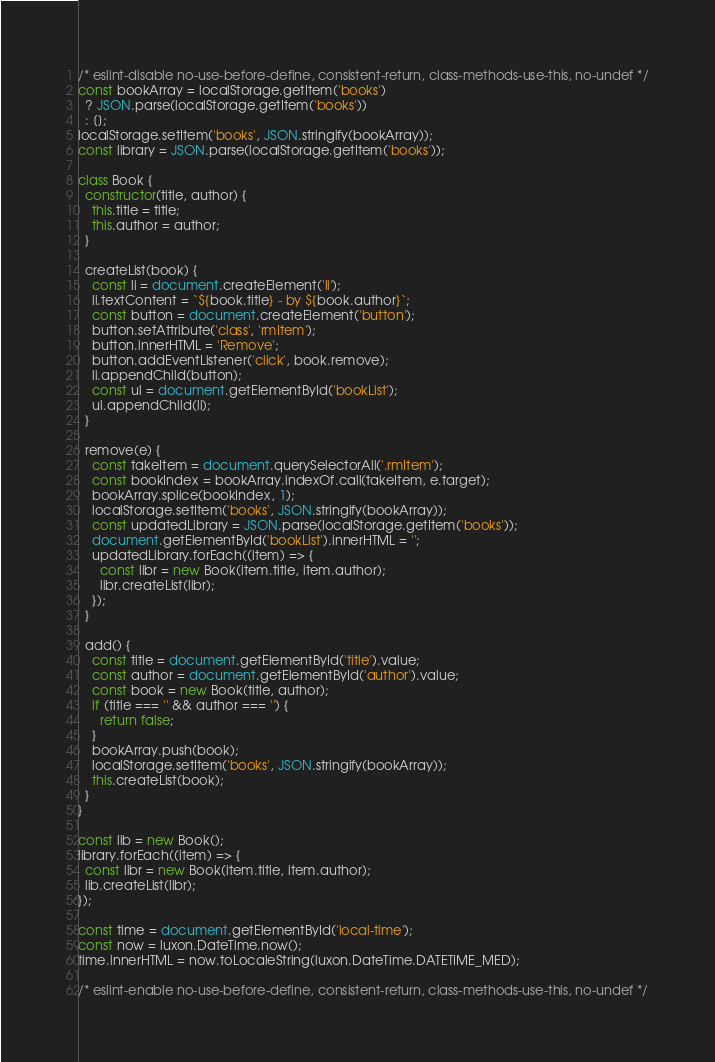<code> <loc_0><loc_0><loc_500><loc_500><_JavaScript_>/* eslint-disable no-use-before-define, consistent-return, class-methods-use-this, no-undef */
const bookArray = localStorage.getItem('books')
  ? JSON.parse(localStorage.getItem('books'))
  : [];
localStorage.setItem('books', JSON.stringify(bookArray));
const library = JSON.parse(localStorage.getItem('books'));

class Book {
  constructor(title, author) {
    this.title = title;
    this.author = author;
  }

  createList(book) {
    const li = document.createElement('li');
    li.textContent = `${book.title} - by ${book.author}`;
    const button = document.createElement('button');
    button.setAttribute('class', 'rmItem');
    button.innerHTML = 'Remove';
    button.addEventListener('click', book.remove);
    li.appendChild(button);
    const ul = document.getElementById('bookList');
    ul.appendChild(li);
  }

  remove(e) {
    const takeItem = document.querySelectorAll('.rmItem');
    const bookIndex = bookArray.indexOf.call(takeItem, e.target);
    bookArray.splice(bookIndex, 1);
    localStorage.setItem('books', JSON.stringify(bookArray));
    const updatedLibrary = JSON.parse(localStorage.getItem('books'));
    document.getElementById('bookList').innerHTML = '';
    updatedLibrary.forEach((item) => {
      const libr = new Book(item.title, item.author);
      libr.createList(libr);
    });
  }

  add() {
    const title = document.getElementById('title').value;
    const author = document.getElementById('author').value;
    const book = new Book(title, author);
    if (title === '' && author === '') {
      return false;
    }
    bookArray.push(book);
    localStorage.setItem('books', JSON.stringify(bookArray));
    this.createList(book);
  }
}

const lib = new Book();
library.forEach((item) => {
  const libr = new Book(item.title, item.author);
  lib.createList(libr);
});

const time = document.getElementById('local-time');
const now = luxon.DateTime.now();
time.innerHTML = now.toLocaleString(luxon.DateTime.DATETIME_MED);

/* eslint-enable no-use-before-define, consistent-return, class-methods-use-this, no-undef */
</code> 